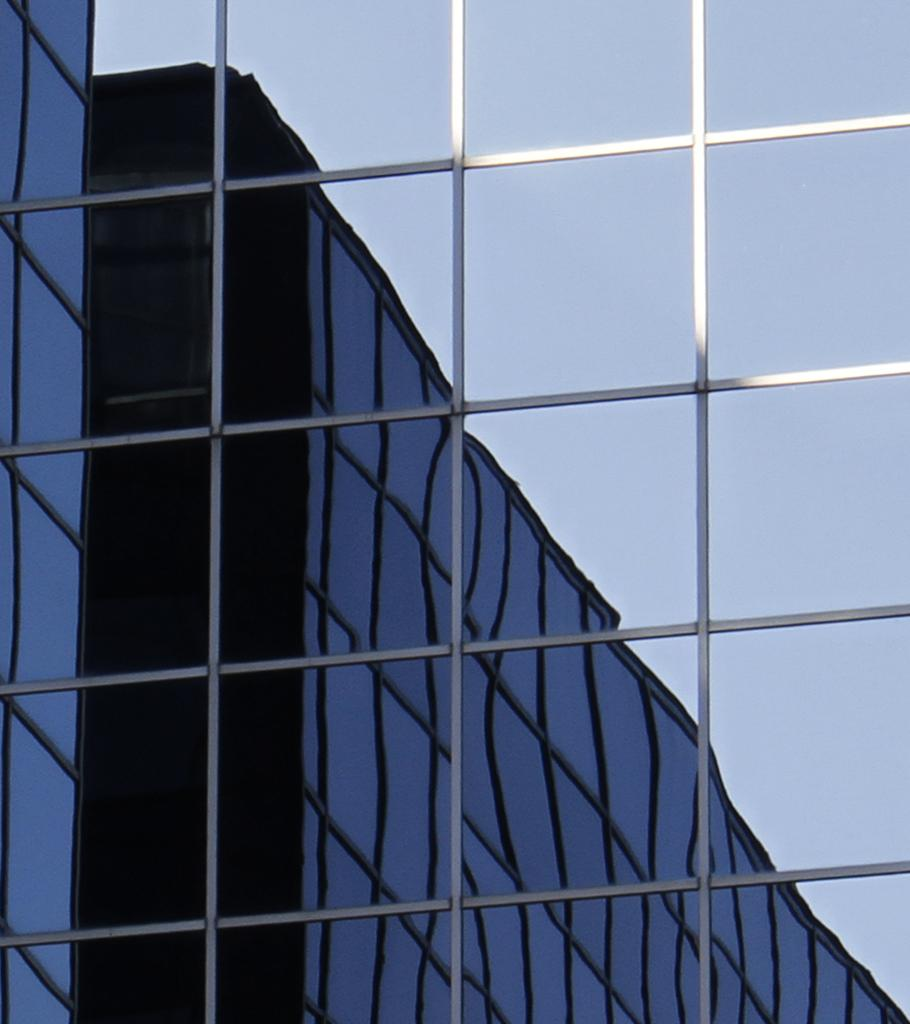What is hanging on the wall in the image? There is a glass on the wall in the image. What does the glass reflect in the image? The glass reflects a building and the sky in the image. Where is the crowd gathered in the image? There is no crowd present in the image; it only features a glass on the wall reflecting a building and the sky. 